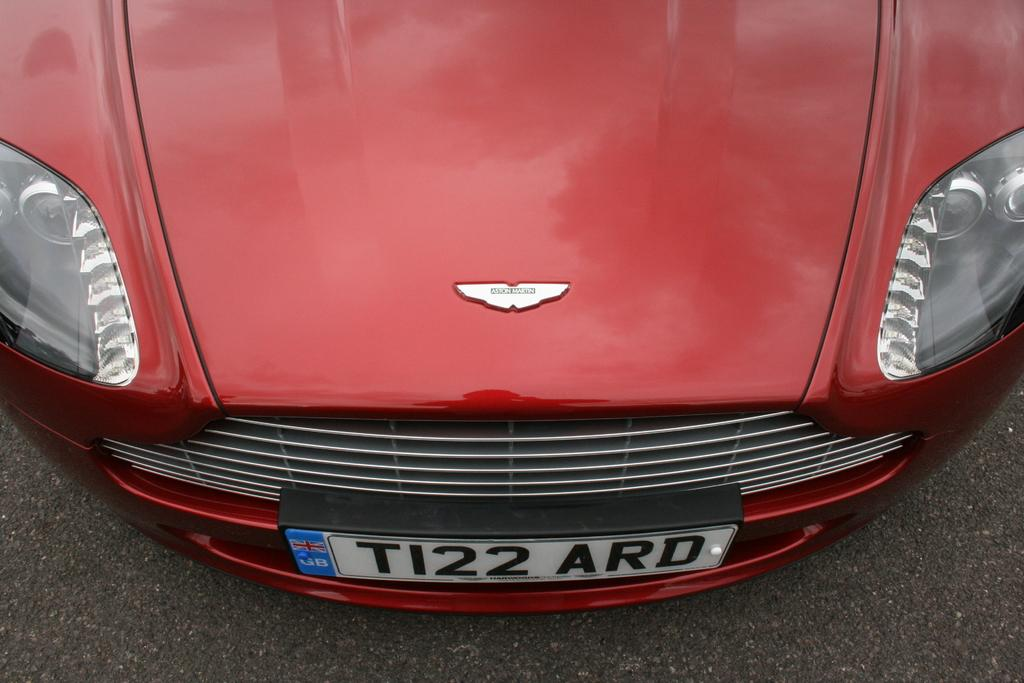What color is the vehicle in the image? The vehicle in the image is red. What is placed on the vehicle? There is a plate on the vehicle. What can be seen on the plate? Something is written on the plate. How many snakes are slithering around the vehicle in the image? There are no snakes present in the image; it only features a red-colored vehicle with a plate on it. 